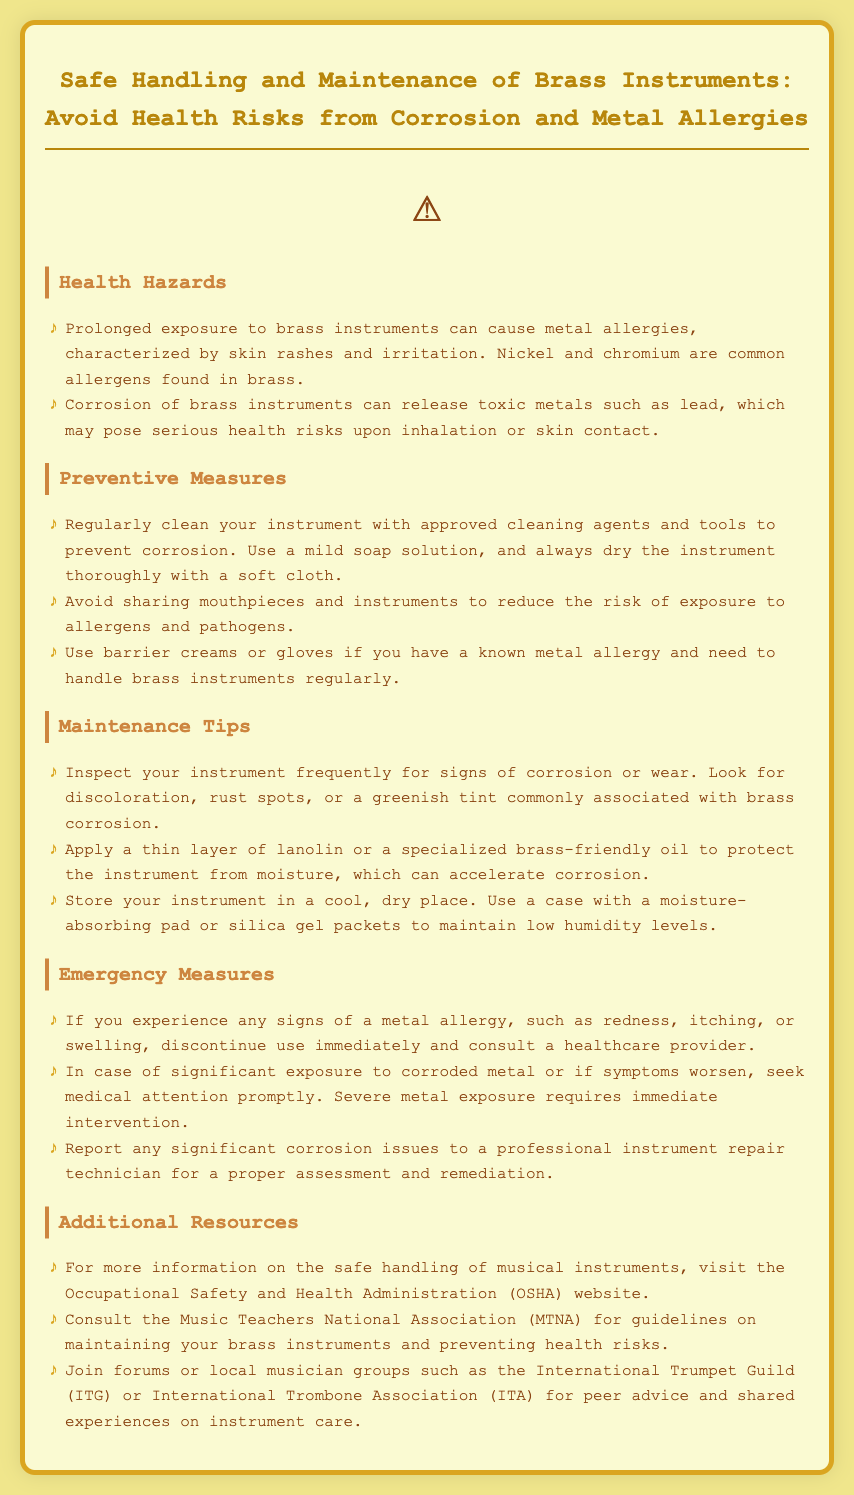What are common allergens found in brass? The document mentions nickel and chromium as common allergens found in brass.
Answer: Nickel and chromium What should you do if you experience signs of a metal allergy? The document advises discontinuing use immediately and consulting a healthcare provider.
Answer: Discontinue use and consult a healthcare provider What is a recommended cleaning agent for brass instruments? The document suggests using a mild soap solution for cleaning brass instruments.
Answer: Mild soap solution Why should you avoid sharing mouthpieces? The document states that sharing can increase the risk of exposure to allergens and pathogens.
Answer: To reduce the risk of exposure to allergens and pathogens What can be applied to protect brass instruments from moisture? The document recommends applying a thin layer of lanolin or a specialized brass-friendly oil.
Answer: Lanolin or brass-friendly oil How can you ensure low humidity levels when storing your instrument? The document suggests using a case with a moisture-absorbing pad or silica gel packets.
Answer: Moisture-absorbing pad or silica gel packets What should you look for during instrument inspection? The document advises looking for discoloration, rust spots, or a greenish tint.
Answer: Discoloration, rust spots, or a greenish tint What is the emergency measure for significant exposure to corroded metal? The document states to seek medical attention promptly.
Answer: Seek medical attention promptly What organization is recommended for guidelines on maintaining brass instruments? The document recommends consulting the Music Teachers National Association (MTNA).
Answer: Music Teachers National Association (MTNA) 